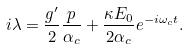<formula> <loc_0><loc_0><loc_500><loc_500>i \lambda = \frac { g ^ { \prime } } { 2 } \frac { p } { \alpha _ { c } } + \frac { \kappa E _ { 0 } } { 2 \alpha _ { c } } e ^ { - i \omega _ { c } t } .</formula> 